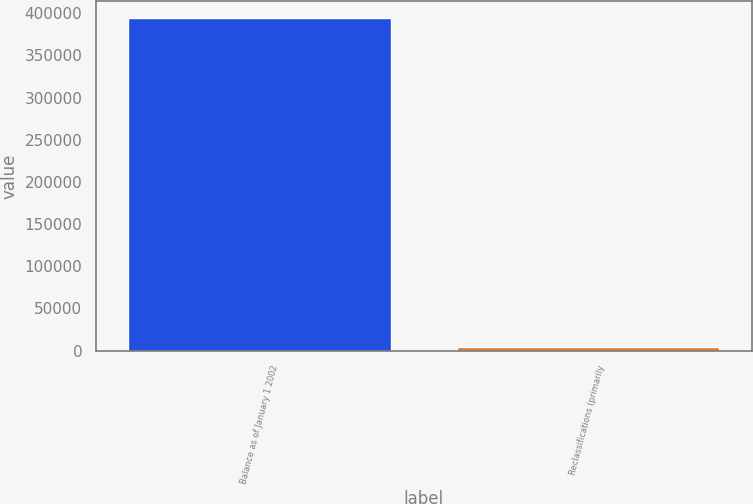Convert chart to OTSL. <chart><loc_0><loc_0><loc_500><loc_500><bar_chart><fcel>Balance as of January 1 2002<fcel>Reclassifications (primarily<nl><fcel>394264<fcel>3799<nl></chart> 